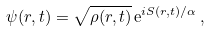Convert formula to latex. <formula><loc_0><loc_0><loc_500><loc_500>\psi ( { r } , t ) = \sqrt { \rho ( { r } , t ) } \, { \mathrm e } ^ { i S ( { r } , t ) / \alpha } \, ,</formula> 